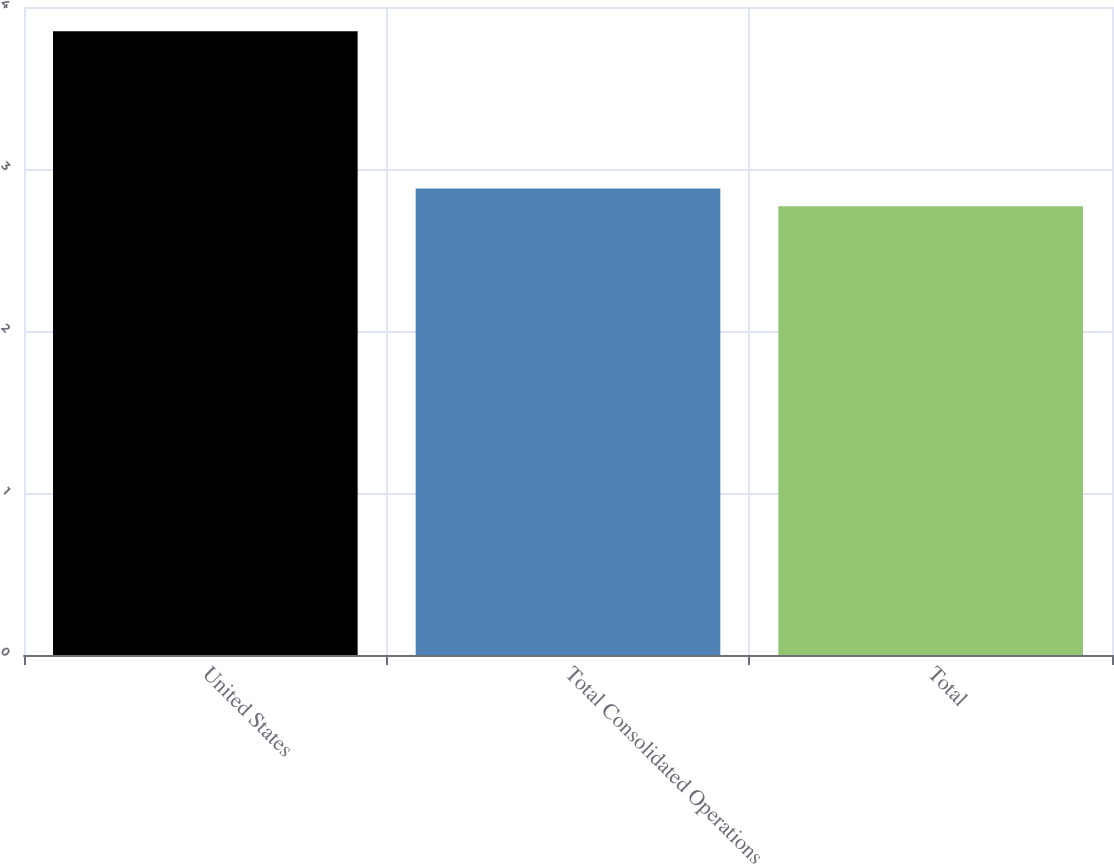Convert chart. <chart><loc_0><loc_0><loc_500><loc_500><bar_chart><fcel>United States<fcel>Total Consolidated Operations<fcel>Total<nl><fcel>3.85<fcel>2.88<fcel>2.77<nl></chart> 